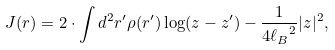Convert formula to latex. <formula><loc_0><loc_0><loc_500><loc_500>J ( { r } ) = 2 \cdot \int d ^ { 2 } { r } ^ { \prime } \rho ( { r } ^ { \prime } ) \log ( z - z ^ { \prime } ) - \frac { 1 } { 4 { \ell _ { B } } ^ { 2 } } | z | ^ { 2 } ,</formula> 